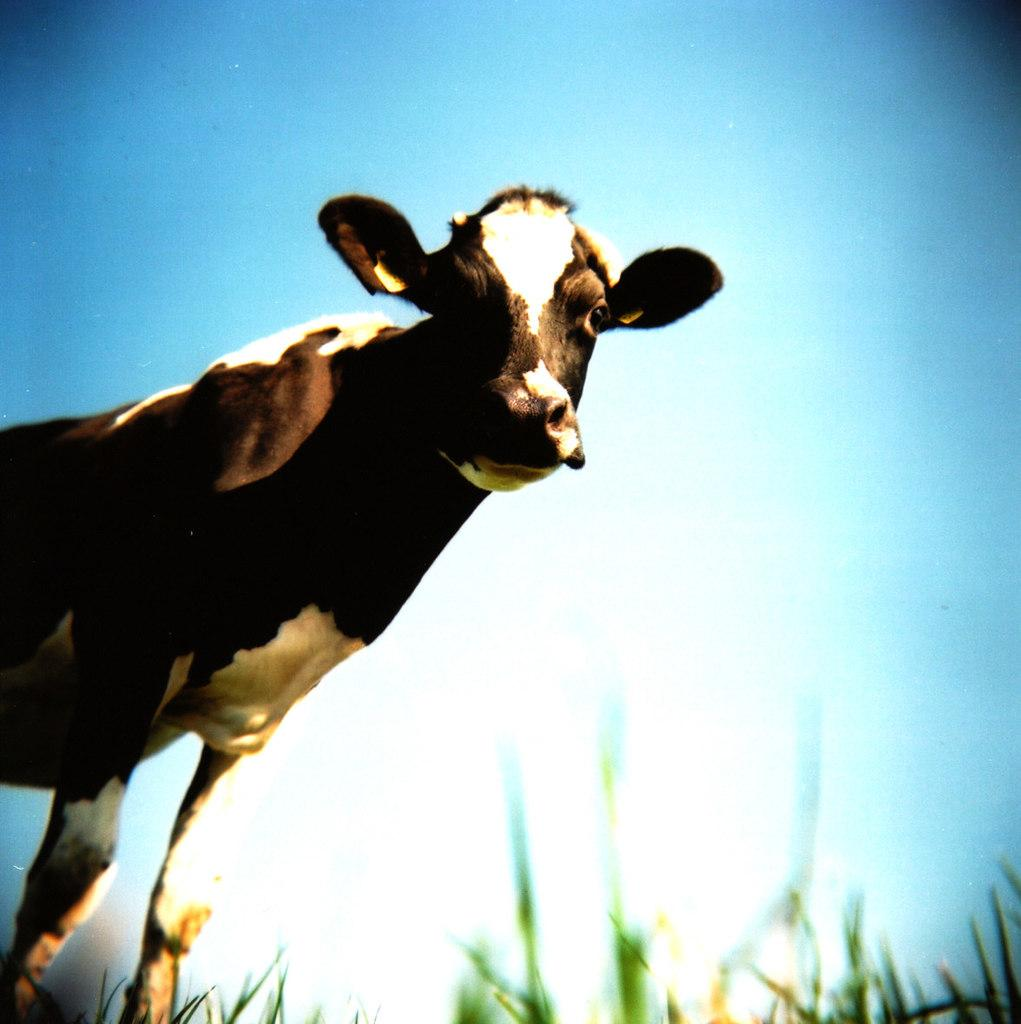What animal is present in the image? There is a cow in the image. What is the cow doing in the image? The cow is standing in the image. What type of vegetation is visible in the image? There is grass in the image. What type of cushion is the cow sitting on in the image? There is no cushion present in the image, and the cow is standing, not sitting. 